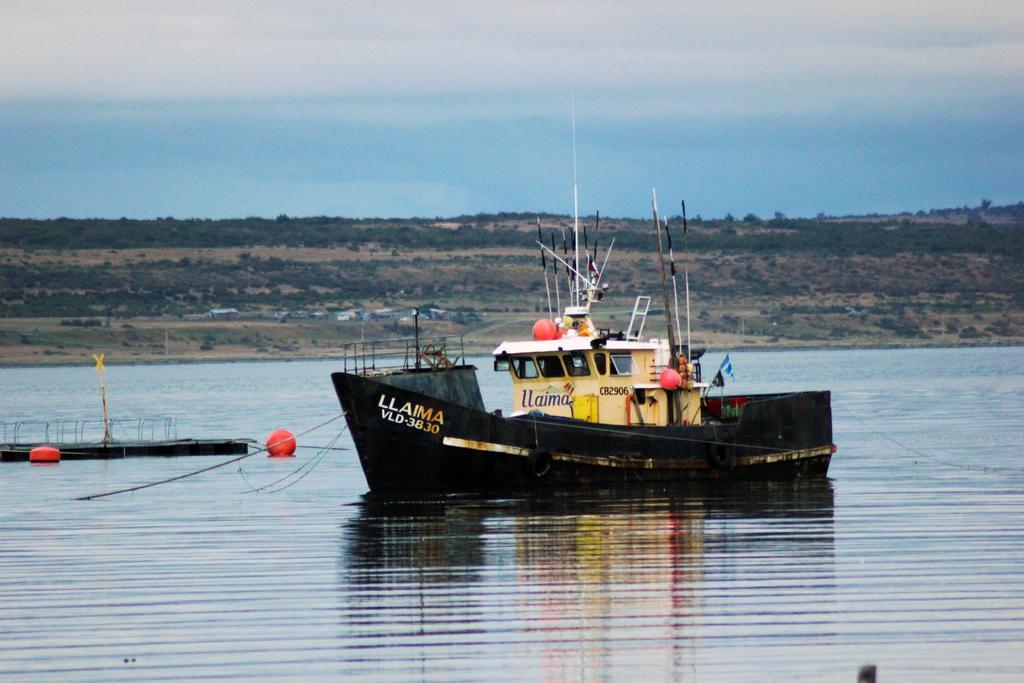In one or two sentences, can you explain what this image depicts? We can see ship and red objects above the water. In the background we can see trees and sky. 